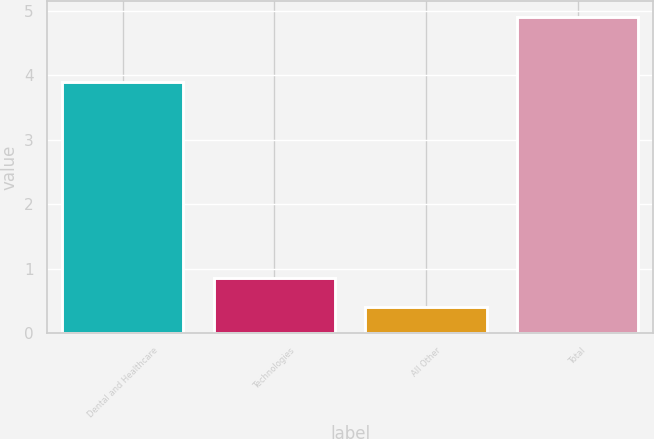Convert chart. <chart><loc_0><loc_0><loc_500><loc_500><bar_chart><fcel>Dental and Healthcare<fcel>Technologies<fcel>All Other<fcel>Total<nl><fcel>3.9<fcel>0.85<fcel>0.4<fcel>4.9<nl></chart> 